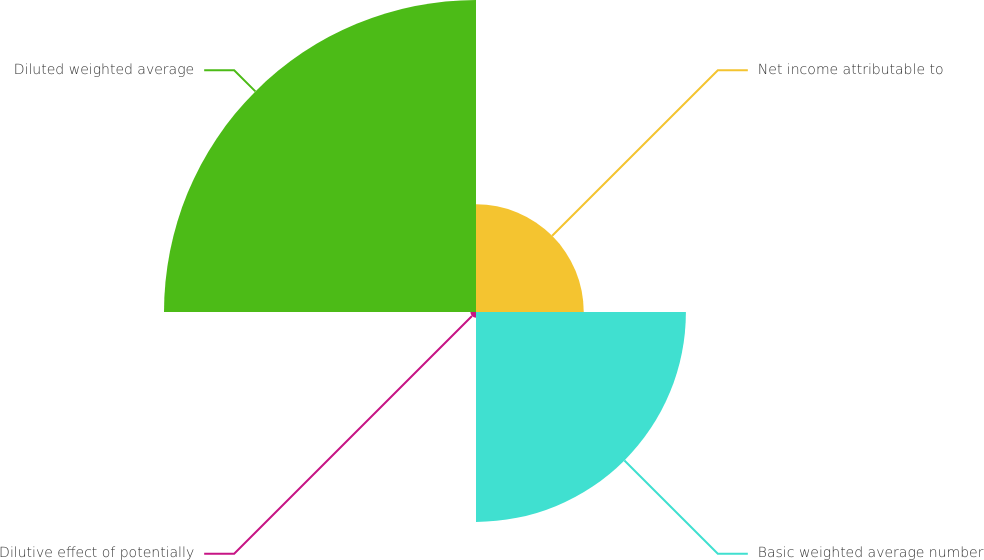Convert chart to OTSL. <chart><loc_0><loc_0><loc_500><loc_500><pie_chart><fcel>Net income attributable to<fcel>Basic weighted average number<fcel>Dilutive effect of potentially<fcel>Diluted weighted average<nl><fcel>16.96%<fcel>33.04%<fcel>0.89%<fcel>49.11%<nl></chart> 